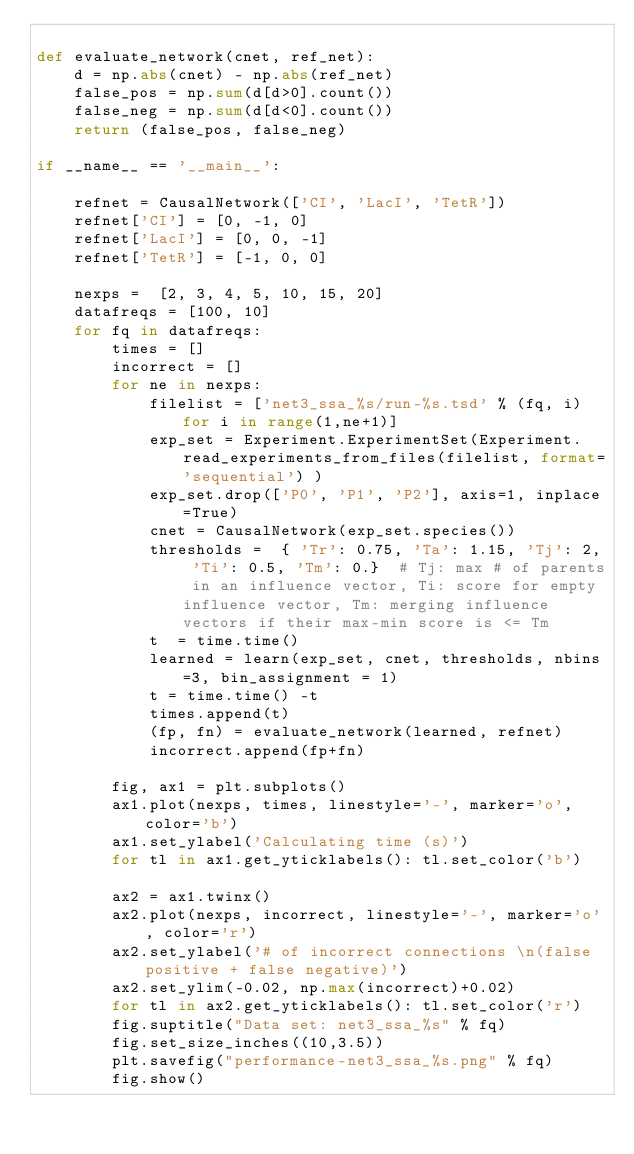Convert code to text. <code><loc_0><loc_0><loc_500><loc_500><_Python_>
def evaluate_network(cnet, ref_net):
    d = np.abs(cnet) - np.abs(ref_net)
    false_pos = np.sum(d[d>0].count())
    false_neg = np.sum(d[d<0].count())
    return (false_pos, false_neg)
    
if __name__ == '__main__':
   
    refnet = CausalNetwork(['CI', 'LacI', 'TetR'])
    refnet['CI'] = [0, -1, 0]
    refnet['LacI'] = [0, 0, -1]
    refnet['TetR'] = [-1, 0, 0]

    nexps =  [2, 3, 4, 5, 10, 15, 20]
    datafreqs = [100, 10]
    for fq in datafreqs:
        times = []
        incorrect = []
        for ne in nexps:
            filelist = ['net3_ssa_%s/run-%s.tsd' % (fq, i) for i in range(1,ne+1)]
            exp_set = Experiment.ExperimentSet(Experiment.read_experiments_from_files(filelist, format='sequential') )
            exp_set.drop(['P0', 'P1', 'P2'], axis=1, inplace=True)
            cnet = CausalNetwork(exp_set.species())
            thresholds =  { 'Tr': 0.75, 'Ta': 1.15, 'Tj': 2, 'Ti': 0.5, 'Tm': 0.}  # Tj: max # of parents in an influence vector, Ti: score for empty influence vector, Tm: merging influence vectors if their max-min score is <= Tm
            t  = time.time()
            learned = learn(exp_set, cnet, thresholds, nbins=3, bin_assignment = 1)
            t = time.time() -t 
            times.append(t)
            (fp, fn) = evaluate_network(learned, refnet)
            incorrect.append(fp+fn)

        fig, ax1 = plt.subplots()
        ax1.plot(nexps, times, linestyle='-', marker='o', color='b')
        ax1.set_ylabel('Calculating time (s)')
        for tl in ax1.get_yticklabels(): tl.set_color('b')

        ax2 = ax1.twinx()
        ax2.plot(nexps, incorrect, linestyle='-', marker='o', color='r')
        ax2.set_ylabel('# of incorrect connections \n(false positive + false negative)')
        ax2.set_ylim(-0.02, np.max(incorrect)+0.02)
        for tl in ax2.get_yticklabels(): tl.set_color('r')
        fig.suptitle("Data set: net3_ssa_%s" % fq)
        fig.set_size_inches((10,3.5))
        plt.savefig("performance-net3_ssa_%s.png" % fq)
        fig.show()
</code> 